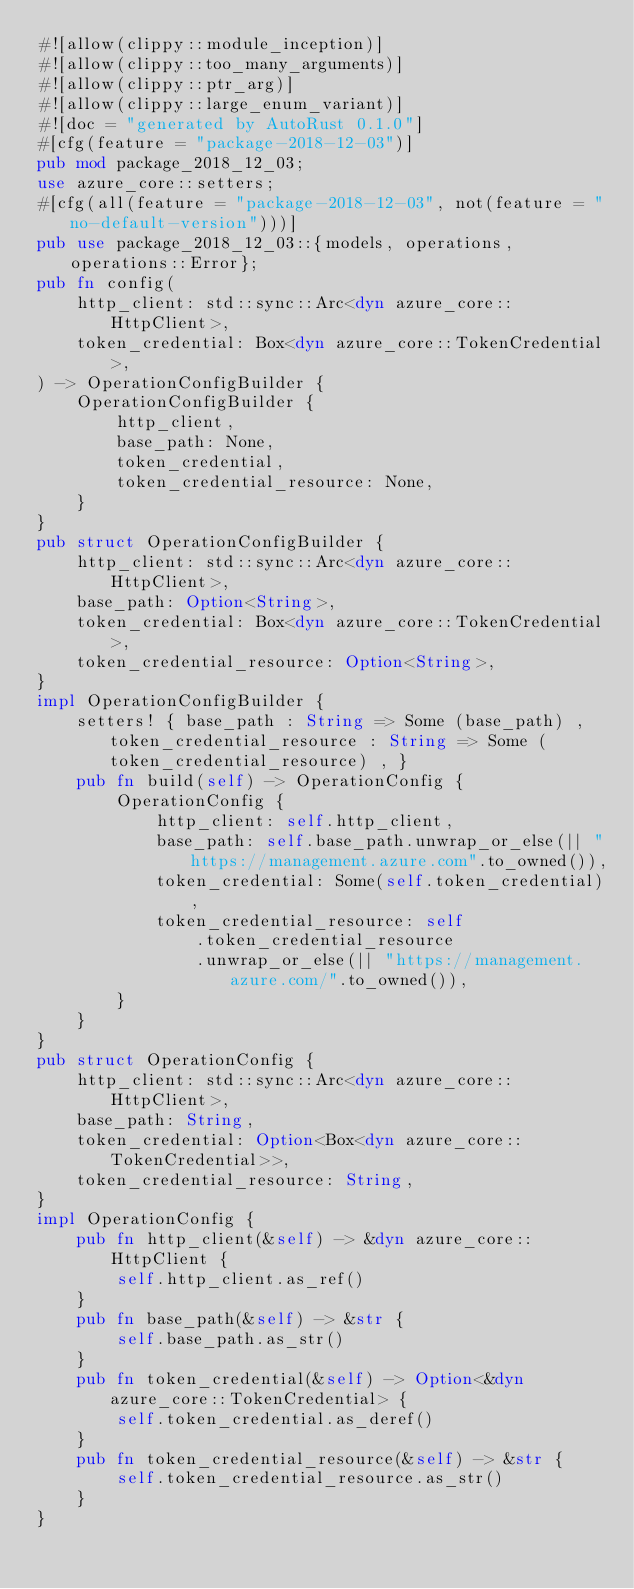Convert code to text. <code><loc_0><loc_0><loc_500><loc_500><_Rust_>#![allow(clippy::module_inception)]
#![allow(clippy::too_many_arguments)]
#![allow(clippy::ptr_arg)]
#![allow(clippy::large_enum_variant)]
#![doc = "generated by AutoRust 0.1.0"]
#[cfg(feature = "package-2018-12-03")]
pub mod package_2018_12_03;
use azure_core::setters;
#[cfg(all(feature = "package-2018-12-03", not(feature = "no-default-version")))]
pub use package_2018_12_03::{models, operations, operations::Error};
pub fn config(
    http_client: std::sync::Arc<dyn azure_core::HttpClient>,
    token_credential: Box<dyn azure_core::TokenCredential>,
) -> OperationConfigBuilder {
    OperationConfigBuilder {
        http_client,
        base_path: None,
        token_credential,
        token_credential_resource: None,
    }
}
pub struct OperationConfigBuilder {
    http_client: std::sync::Arc<dyn azure_core::HttpClient>,
    base_path: Option<String>,
    token_credential: Box<dyn azure_core::TokenCredential>,
    token_credential_resource: Option<String>,
}
impl OperationConfigBuilder {
    setters! { base_path : String => Some (base_path) , token_credential_resource : String => Some (token_credential_resource) , }
    pub fn build(self) -> OperationConfig {
        OperationConfig {
            http_client: self.http_client,
            base_path: self.base_path.unwrap_or_else(|| "https://management.azure.com".to_owned()),
            token_credential: Some(self.token_credential),
            token_credential_resource: self
                .token_credential_resource
                .unwrap_or_else(|| "https://management.azure.com/".to_owned()),
        }
    }
}
pub struct OperationConfig {
    http_client: std::sync::Arc<dyn azure_core::HttpClient>,
    base_path: String,
    token_credential: Option<Box<dyn azure_core::TokenCredential>>,
    token_credential_resource: String,
}
impl OperationConfig {
    pub fn http_client(&self) -> &dyn azure_core::HttpClient {
        self.http_client.as_ref()
    }
    pub fn base_path(&self) -> &str {
        self.base_path.as_str()
    }
    pub fn token_credential(&self) -> Option<&dyn azure_core::TokenCredential> {
        self.token_credential.as_deref()
    }
    pub fn token_credential_resource(&self) -> &str {
        self.token_credential_resource.as_str()
    }
}
</code> 